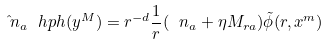<formula> <loc_0><loc_0><loc_500><loc_500>\hat { \ n } _ { a } \ h p h ( y ^ { M } ) = r ^ { - d } \frac { 1 } { r } ( \ n _ { a } + \eta M _ { r a } ) \tilde { \phi } ( r , x ^ { m } )</formula> 